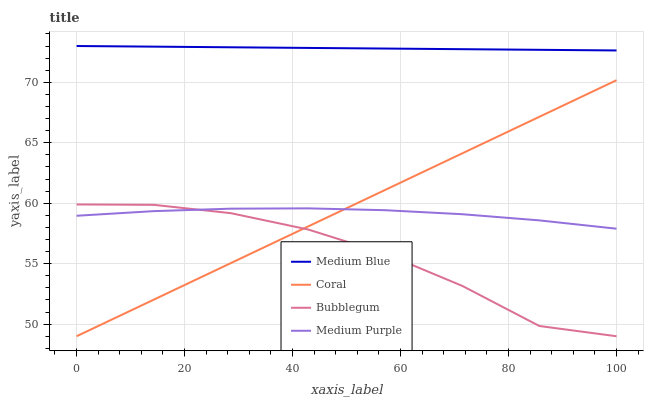Does Bubblegum have the minimum area under the curve?
Answer yes or no. Yes. Does Medium Blue have the maximum area under the curve?
Answer yes or no. Yes. Does Coral have the minimum area under the curve?
Answer yes or no. No. Does Coral have the maximum area under the curve?
Answer yes or no. No. Is Medium Blue the smoothest?
Answer yes or no. Yes. Is Bubblegum the roughest?
Answer yes or no. Yes. Is Coral the smoothest?
Answer yes or no. No. Is Coral the roughest?
Answer yes or no. No. Does Coral have the lowest value?
Answer yes or no. Yes. Does Medium Blue have the lowest value?
Answer yes or no. No. Does Medium Blue have the highest value?
Answer yes or no. Yes. Does Coral have the highest value?
Answer yes or no. No. Is Bubblegum less than Medium Blue?
Answer yes or no. Yes. Is Medium Blue greater than Coral?
Answer yes or no. Yes. Does Bubblegum intersect Medium Purple?
Answer yes or no. Yes. Is Bubblegum less than Medium Purple?
Answer yes or no. No. Is Bubblegum greater than Medium Purple?
Answer yes or no. No. Does Bubblegum intersect Medium Blue?
Answer yes or no. No. 